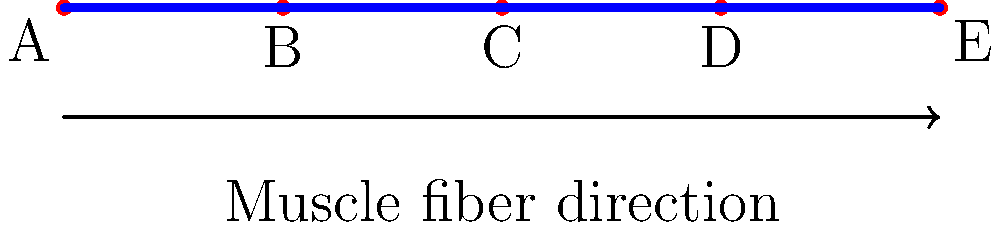Consider a simplified model of interconnected muscle fibers represented as a linear chain, as shown in the diagram. If we define the "connectivity number" of a fiber as the number of other fibers it's directly connected to, what is the sum of the connectivity numbers for all fibers in this model? How does this relate to the topological concept of degree in graph theory? To solve this problem, let's follow these steps:

1. Identify each fiber:
   - We have 5 points (A, B, C, D, E) representing junctions of muscle fibers.
   - There are 4 muscle fibers represented by the line segments between these points.

2. Determine the connectivity number for each fiber:
   - Fiber AB: Connected to BC (1 connection)
   - Fiber BC: Connected to AB and CD (2 connections)
   - Fiber CD: Connected to BC and DE (2 connections)
   - Fiber DE: Connected to CD (1 connection)

3. Sum the connectivity numbers:
   1 + 2 + 2 + 1 = 6

4. Relation to graph theory:
   In graph theory, the degree of a vertex is the number of edges incident to it. In our model:
   - Each fiber can be considered an edge.
   - Each junction point (A, B, C, D, E) can be considered a vertex.
   - The sum of degrees of all vertices in a graph is always twice the number of edges.
   - In our case: (1 + 2 + 2 + 2 + 1) = 8 = 2 * 4 (twice the number of fibers)

5. Topological significance:
   This linear chain structure represents a simple 1-dimensional topology. The sum of connectivity numbers (6) represents the total number of connections in the system, which is a fundamental property in determining the overall structure and function of the muscle fiber network.
Answer: 6; represents total connections in 1D topology, analogous to edge count in graph theory. 